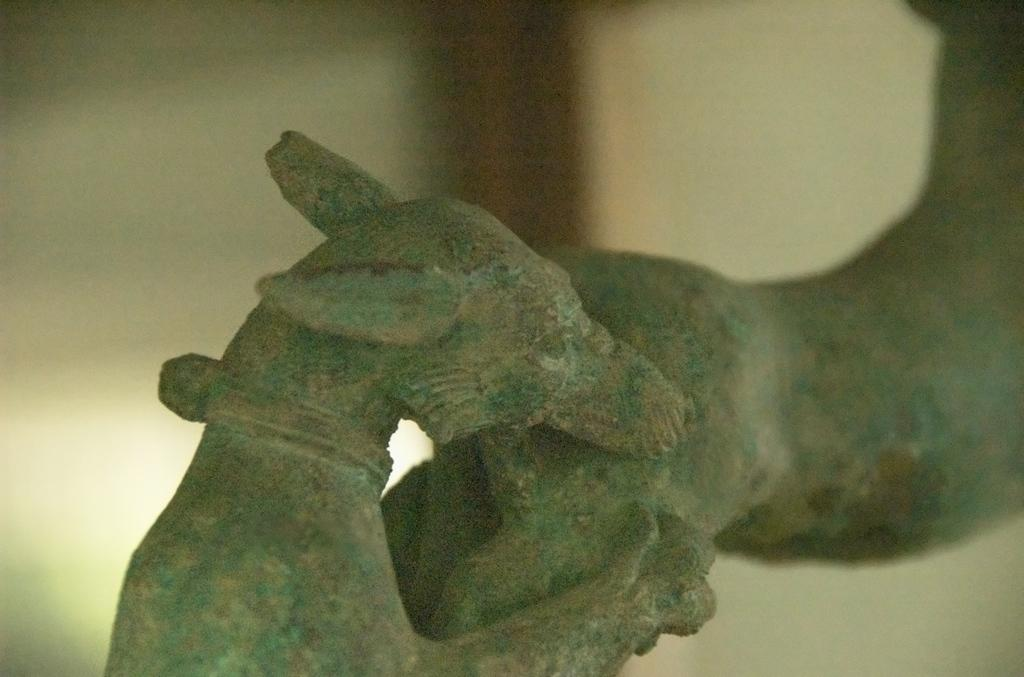What is the main subject of the image? There is a sculpture in the image. How many chickens are flying in the image? There are no chickens present in the image, and therefore no such activity can be observed. 